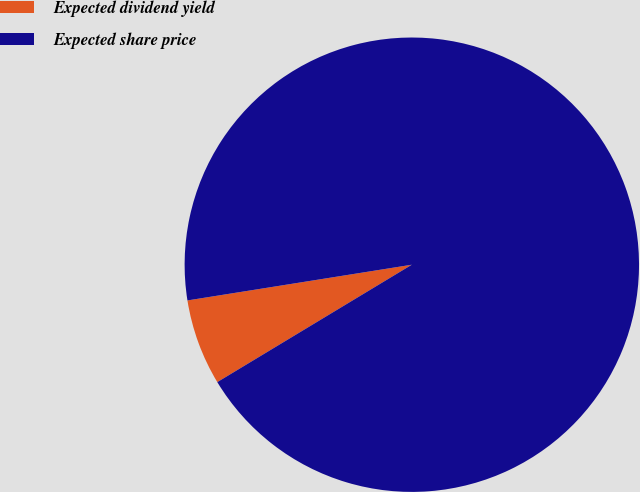<chart> <loc_0><loc_0><loc_500><loc_500><pie_chart><fcel>Expected dividend yield<fcel>Expected share price<nl><fcel>6.13%<fcel>93.87%<nl></chart> 